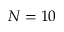Convert formula to latex. <formula><loc_0><loc_0><loc_500><loc_500>N = 1 0</formula> 